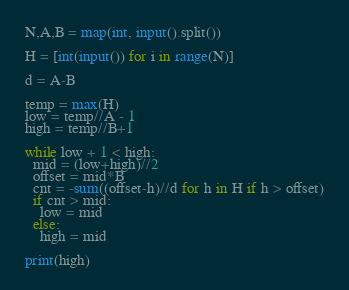<code> <loc_0><loc_0><loc_500><loc_500><_Python_>N,A,B = map(int, input().split())

H = [int(input()) for i in range(N)]

d = A-B

temp = max(H)
low = temp//A - 1
high = temp//B+1

while low + 1 < high:
  mid = (low+high)//2
  offset = mid*B
  cnt = -sum((offset-h)//d for h in H if h > offset)
  if cnt > mid:
    low = mid
  else:
    high = mid

print(high)</code> 